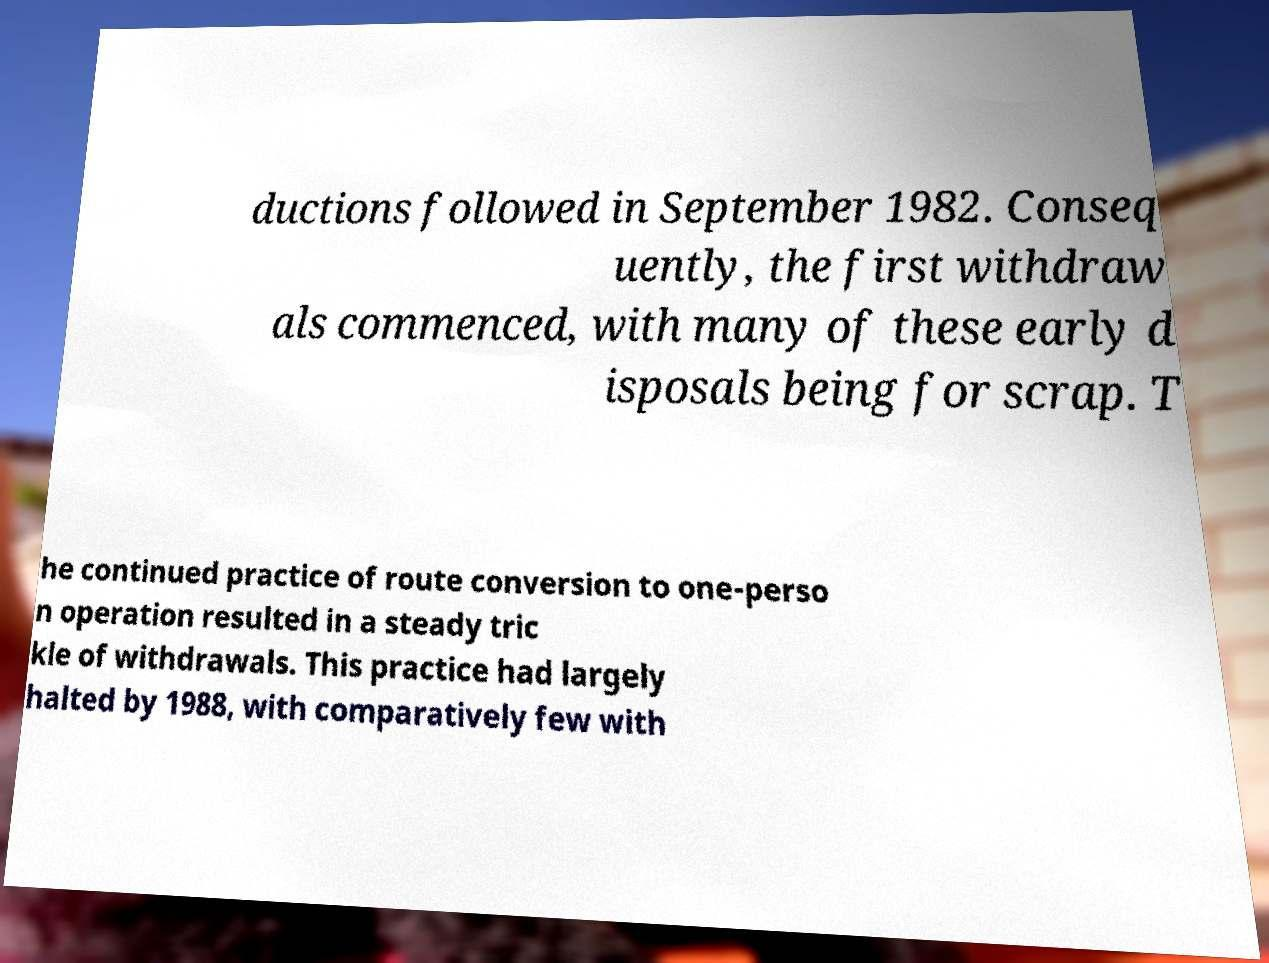Please identify and transcribe the text found in this image. ductions followed in September 1982. Conseq uently, the first withdraw als commenced, with many of these early d isposals being for scrap. T he continued practice of route conversion to one-perso n operation resulted in a steady tric kle of withdrawals. This practice had largely halted by 1988, with comparatively few with 